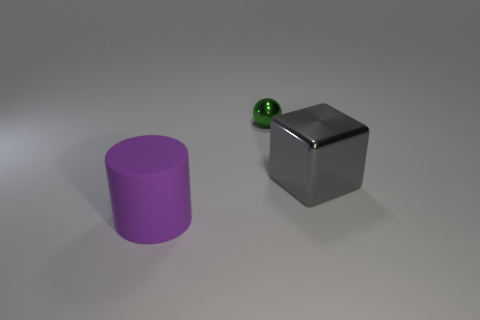Add 3 purple blocks. How many objects exist? 6 Subtract all cubes. How many objects are left? 2 Add 3 objects. How many objects exist? 6 Subtract 0 brown spheres. How many objects are left? 3 Subtract all big yellow cubes. Subtract all shiny objects. How many objects are left? 1 Add 3 big matte cylinders. How many big matte cylinders are left? 4 